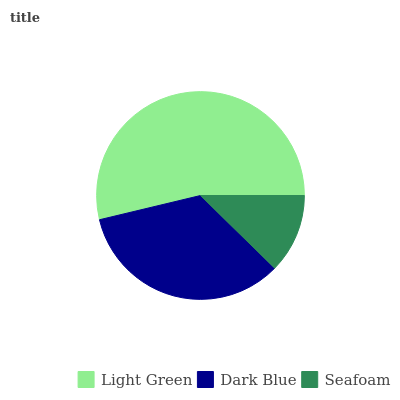Is Seafoam the minimum?
Answer yes or no. Yes. Is Light Green the maximum?
Answer yes or no. Yes. Is Dark Blue the minimum?
Answer yes or no. No. Is Dark Blue the maximum?
Answer yes or no. No. Is Light Green greater than Dark Blue?
Answer yes or no. Yes. Is Dark Blue less than Light Green?
Answer yes or no. Yes. Is Dark Blue greater than Light Green?
Answer yes or no. No. Is Light Green less than Dark Blue?
Answer yes or no. No. Is Dark Blue the high median?
Answer yes or no. Yes. Is Dark Blue the low median?
Answer yes or no. Yes. Is Seafoam the high median?
Answer yes or no. No. Is Seafoam the low median?
Answer yes or no. No. 